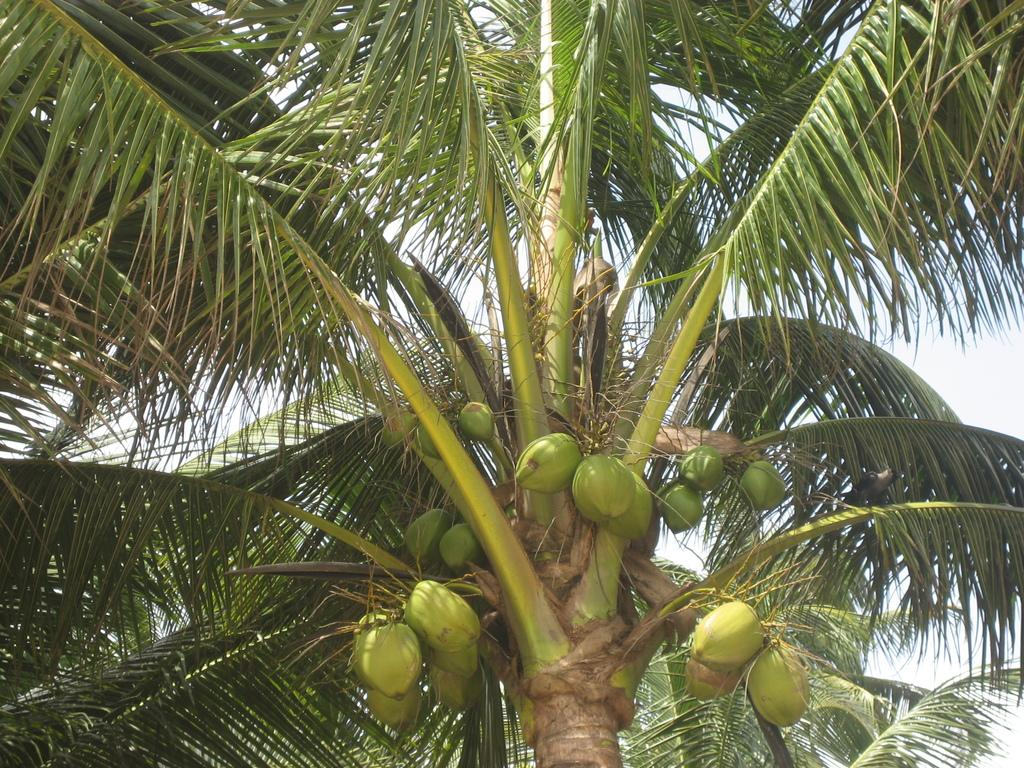What type of tree is present in the image? There is a coconut tree in the image. Can you see the farmer harvesting coconuts from the tree in the image? There is no farmer or any indication of harvesting in the image; it only features a coconut tree. How many teeth can be seen on the tree in the image? Trees do not have teeth, so there are no teeth visible on the coconut tree in the image. 